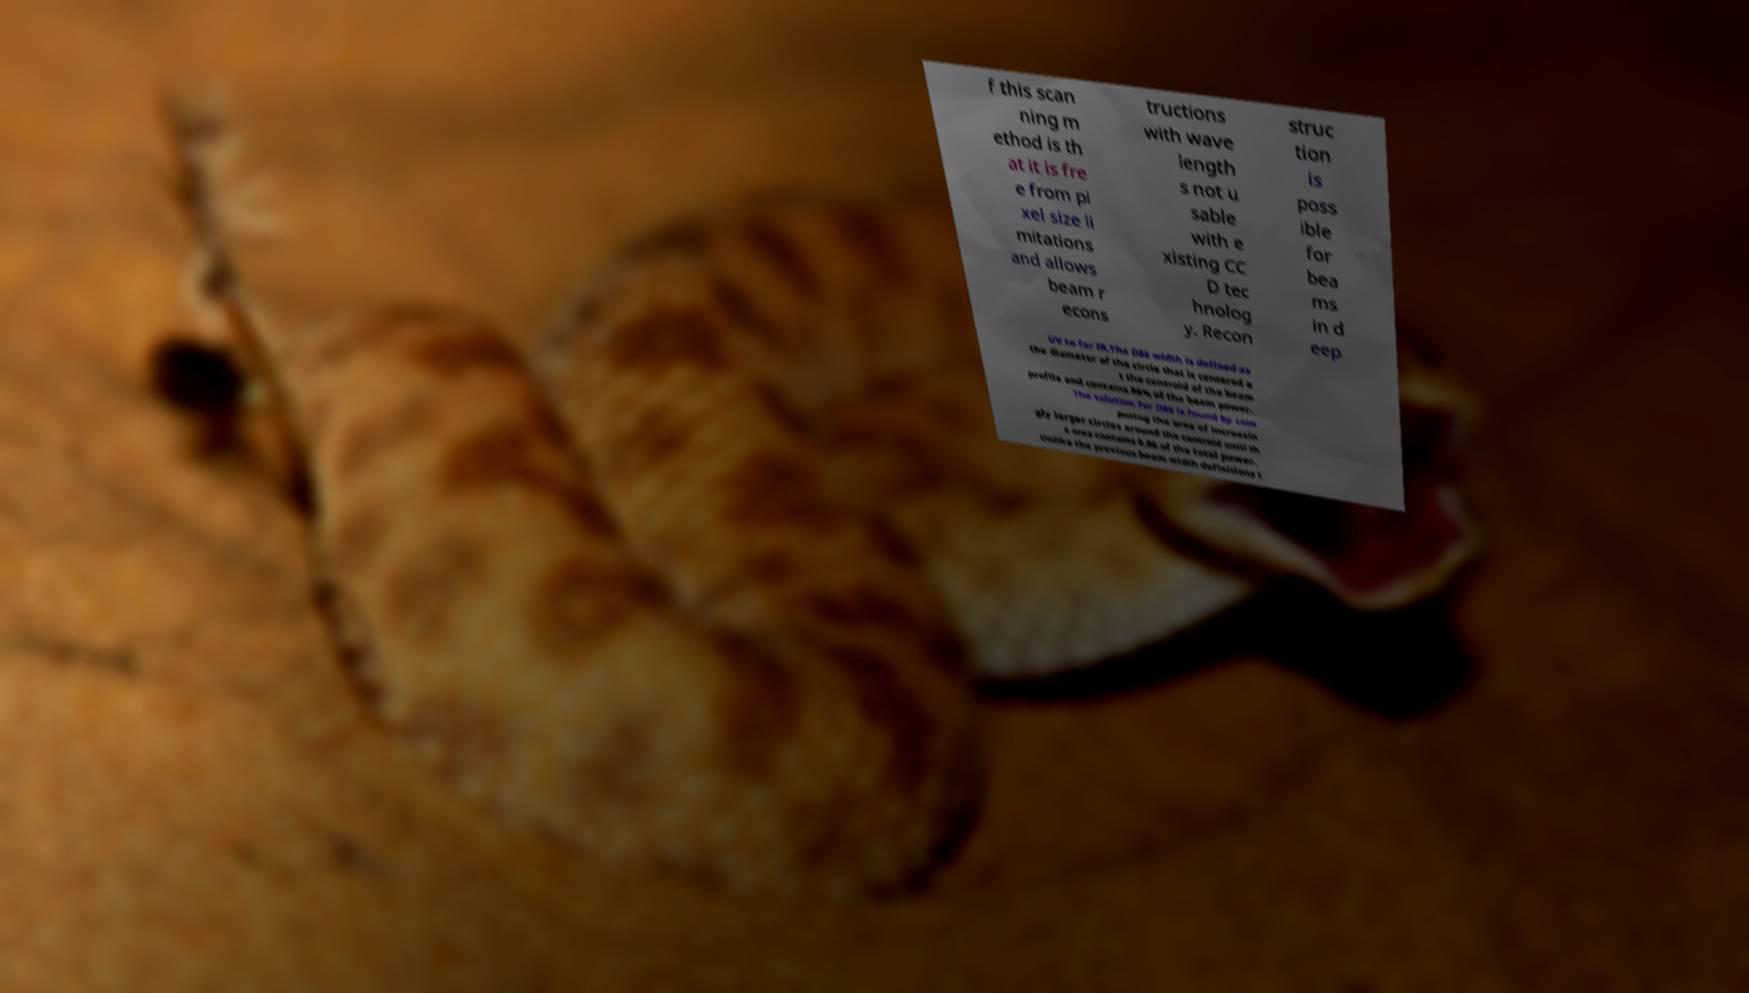What messages or text are displayed in this image? I need them in a readable, typed format. f this scan ning m ethod is th at it is fre e from pi xel size li mitations and allows beam r econs tructions with wave length s not u sable with e xisting CC D tec hnolog y. Recon struc tion is poss ible for bea ms in d eep UV to far IR.The D86 width is defined as the diameter of the circle that is centered a t the centroid of the beam profile and contains 86% of the beam power. The solution for D86 is found by com puting the area of increasin gly larger circles around the centroid until th e area contains 0.86 of the total power. Unlike the previous beam width definitions t 